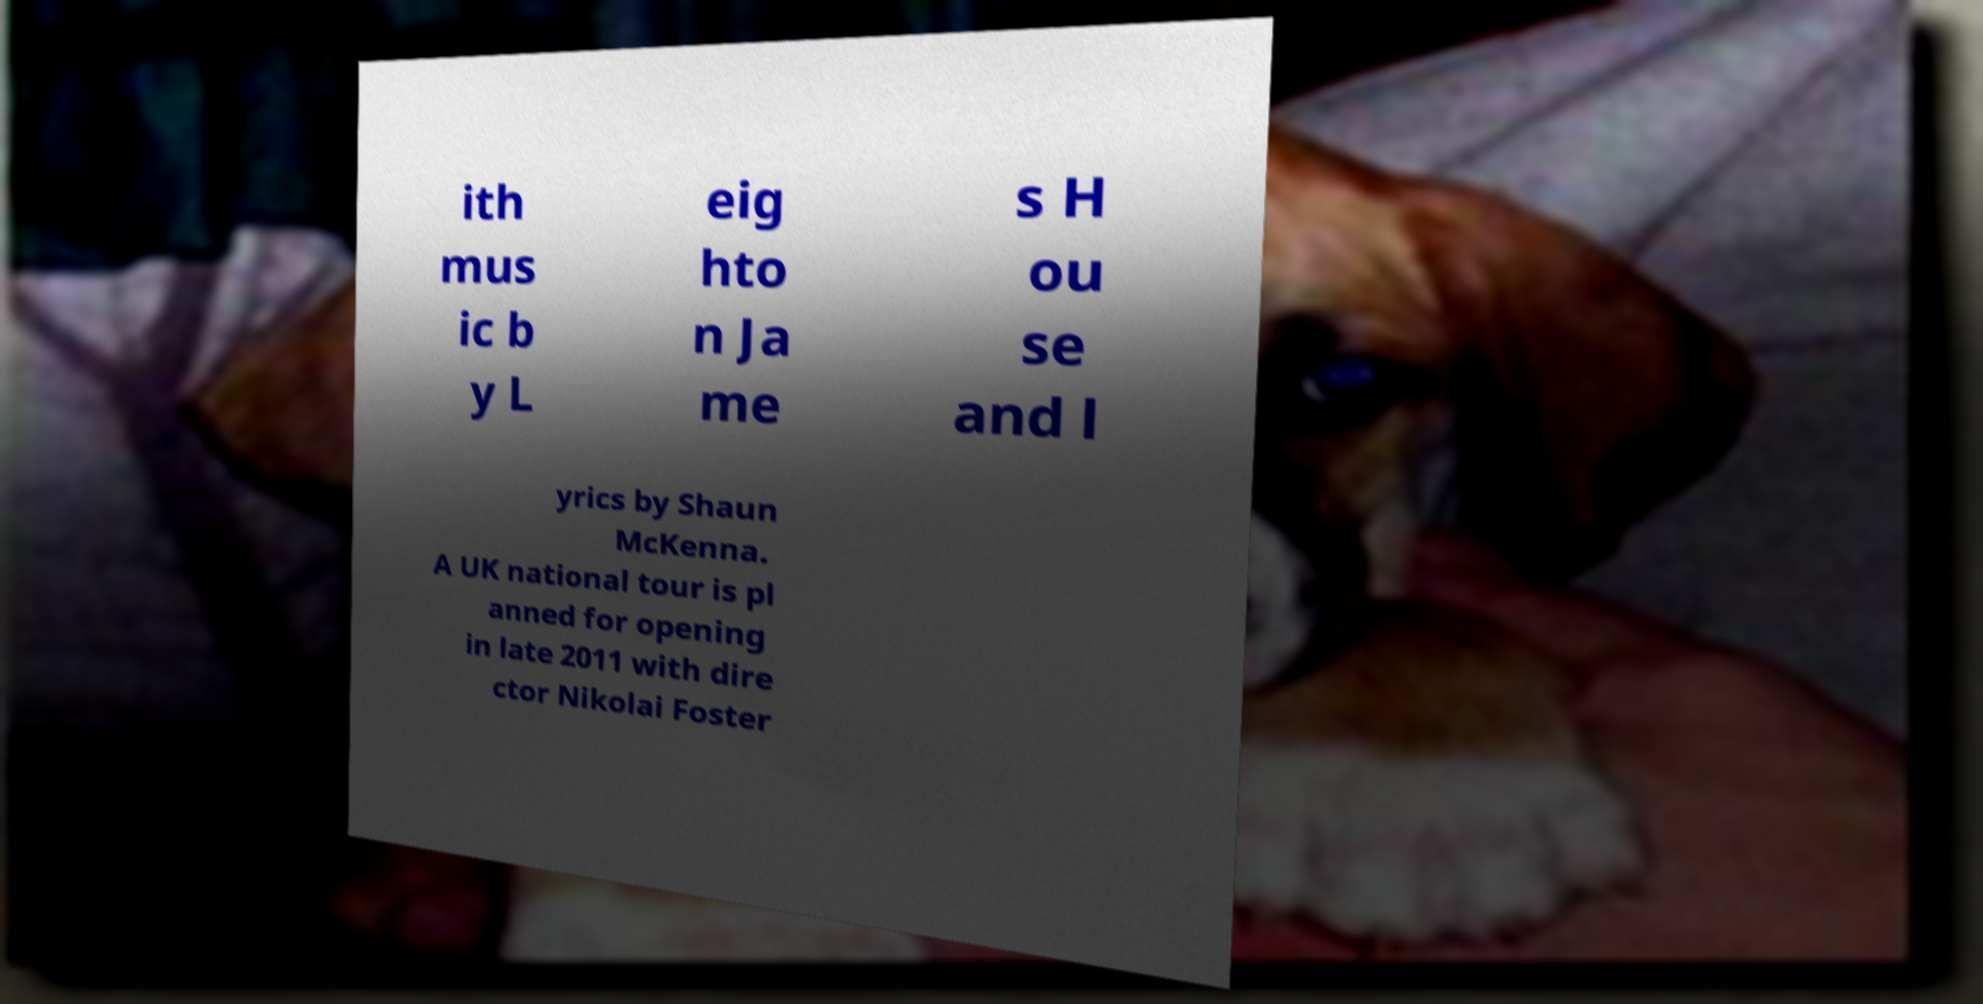What messages or text are displayed in this image? I need them in a readable, typed format. ith mus ic b y L eig hto n Ja me s H ou se and l yrics by Shaun McKenna. A UK national tour is pl anned for opening in late 2011 with dire ctor Nikolai Foster 